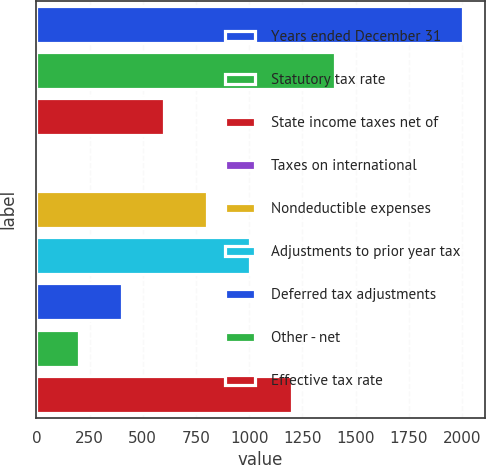Convert chart to OTSL. <chart><loc_0><loc_0><loc_500><loc_500><bar_chart><fcel>Years ended December 31<fcel>Statutory tax rate<fcel>State income taxes net of<fcel>Taxes on international<fcel>Nondeductible expenses<fcel>Adjustments to prior year tax<fcel>Deferred tax adjustments<fcel>Other - net<fcel>Effective tax rate<nl><fcel>2005<fcel>1403.68<fcel>601.92<fcel>0.6<fcel>802.36<fcel>1002.8<fcel>401.48<fcel>201.04<fcel>1203.24<nl></chart> 